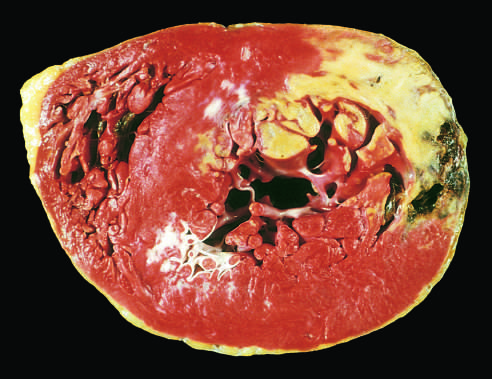what is demonstrated by a lack of triphenyltetrazolium chloride staining in areas of necrosis?
Answer the question using a single word or phrase. Acute myocardial infarct of the posterolateral left ventricle 